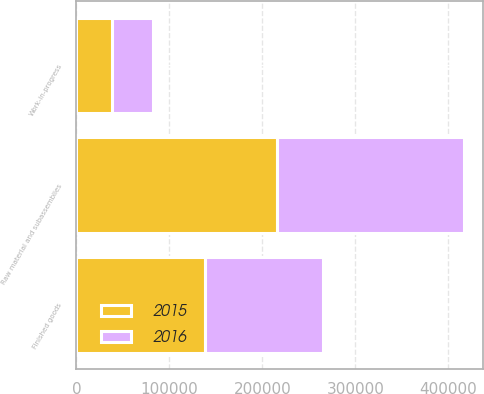<chart> <loc_0><loc_0><loc_500><loc_500><stacked_bar_chart><ecel><fcel>Raw material and subassemblies<fcel>Work-in-progress<fcel>Finished goods<nl><fcel>2016<fcel>200640<fcel>43430<fcel>127301<nl><fcel>2015<fcel>216107<fcel>38639<fcel>138346<nl></chart> 